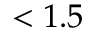Convert formula to latex. <formula><loc_0><loc_0><loc_500><loc_500>< 1 . 5</formula> 